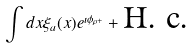<formula> <loc_0><loc_0><loc_500><loc_500>\int d x \xi _ { a } ( x ) e ^ { \imath \phi _ { \rho + } } + \text {H. c.}</formula> 